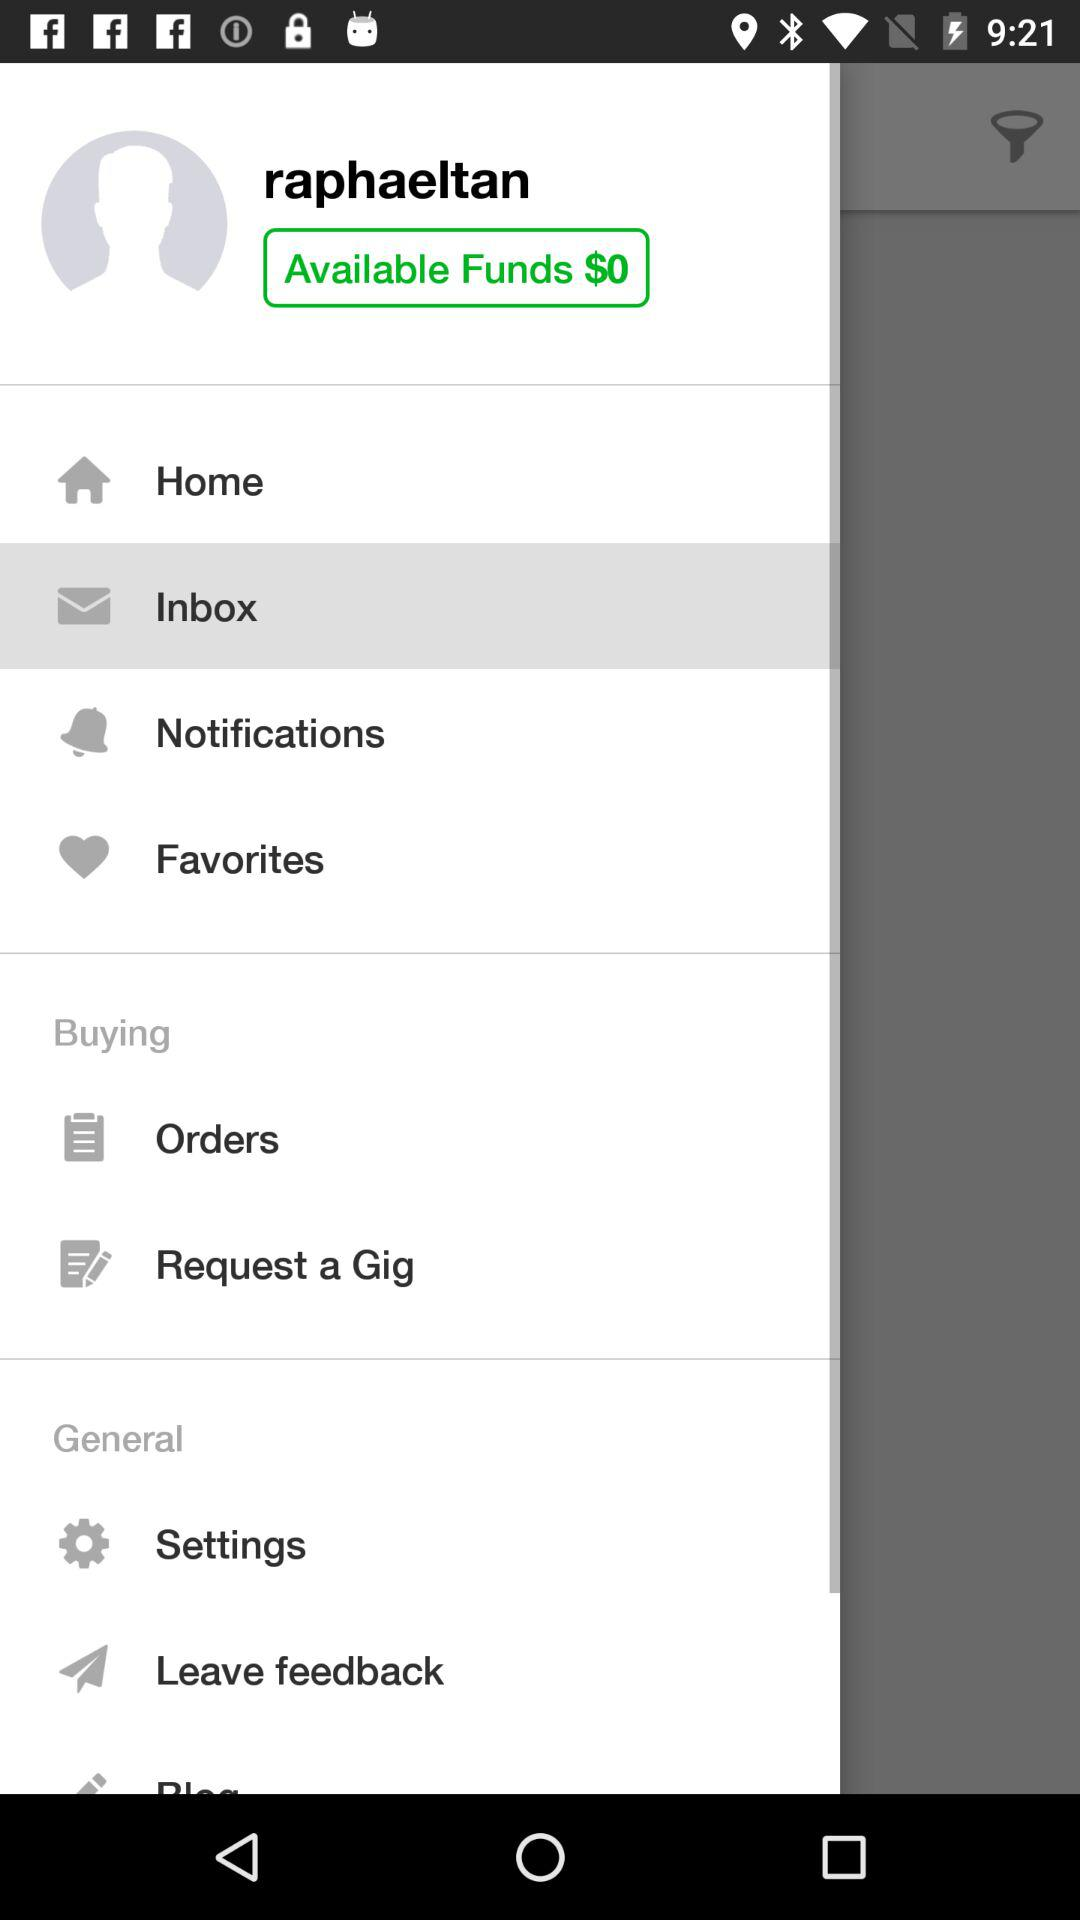How much do I have in available funds?
Answer the question using a single word or phrase. $0 